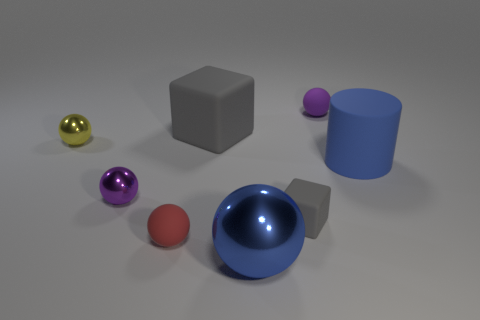There is another rubber block that is the same color as the large cube; what size is it?
Provide a short and direct response. Small. Is the shape of the small red matte object the same as the large blue matte object?
Make the answer very short. No. The purple matte object that is the same shape as the tiny red matte thing is what size?
Provide a short and direct response. Small. There is a yellow shiny ball; does it have the same size as the rubber ball to the right of the small rubber block?
Provide a short and direct response. Yes. What shape is the big thing right of the purple rubber sphere?
Offer a terse response. Cylinder. There is a rubber cylinder right of the shiny object right of the red ball; what color is it?
Your response must be concise. Blue. There is another rubber object that is the same shape as the red object; what is its color?
Provide a succinct answer. Purple. What number of tiny spheres are the same color as the large shiny object?
Offer a very short reply. 0. There is a large ball; does it have the same color as the cylinder behind the small purple shiny ball?
Ensure brevity in your answer.  Yes. There is a matte thing that is both on the left side of the small matte block and in front of the tiny yellow metallic thing; what is its shape?
Your answer should be very brief. Sphere. 